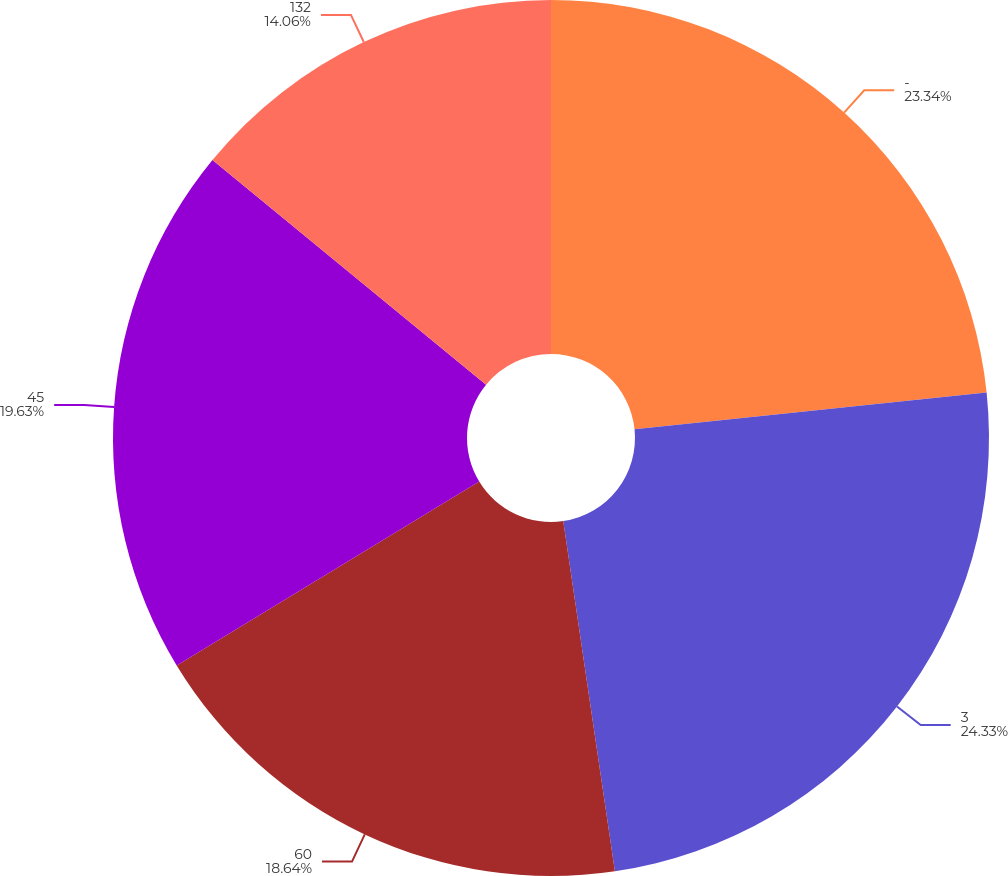Convert chart. <chart><loc_0><loc_0><loc_500><loc_500><pie_chart><fcel>-<fcel>3<fcel>60<fcel>45<fcel>132<nl><fcel>23.34%<fcel>24.33%<fcel>18.64%<fcel>19.63%<fcel>14.06%<nl></chart> 